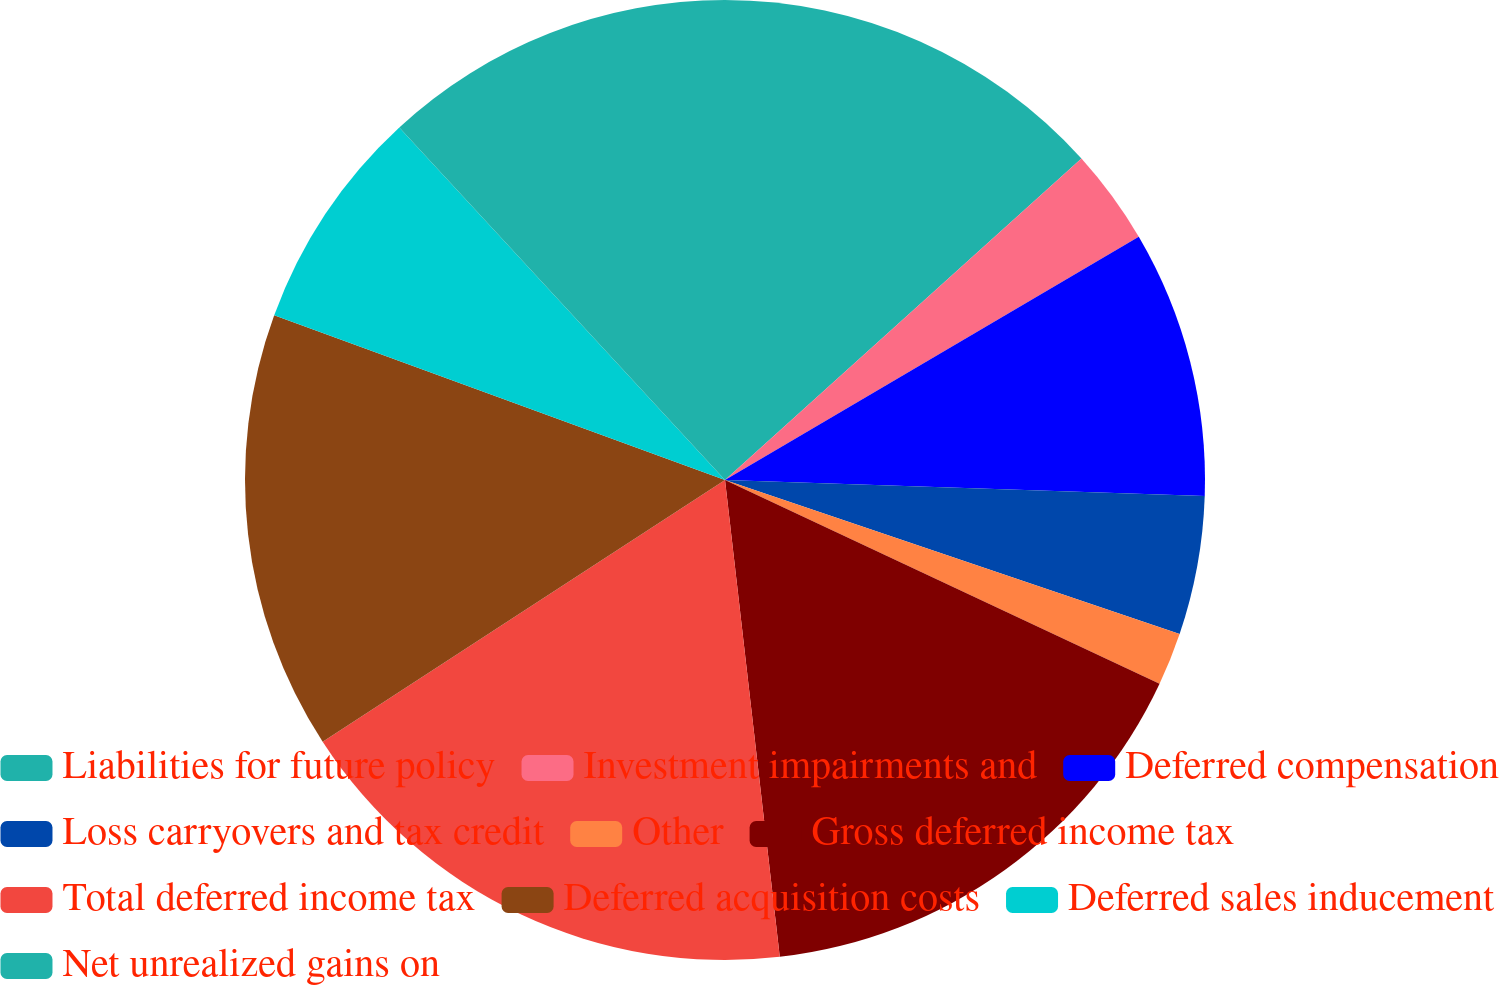Convert chart. <chart><loc_0><loc_0><loc_500><loc_500><pie_chart><fcel>Liabilities for future policy<fcel>Investment impairments and<fcel>Deferred compensation<fcel>Loss carryovers and tax credit<fcel>Other<fcel>Gross deferred income tax<fcel>Total deferred income tax<fcel>Deferred acquisition costs<fcel>Deferred sales inducement<fcel>Net unrealized gains on<nl><fcel>13.32%<fcel>3.22%<fcel>8.99%<fcel>4.67%<fcel>1.78%<fcel>16.2%<fcel>17.64%<fcel>14.76%<fcel>7.55%<fcel>11.87%<nl></chart> 